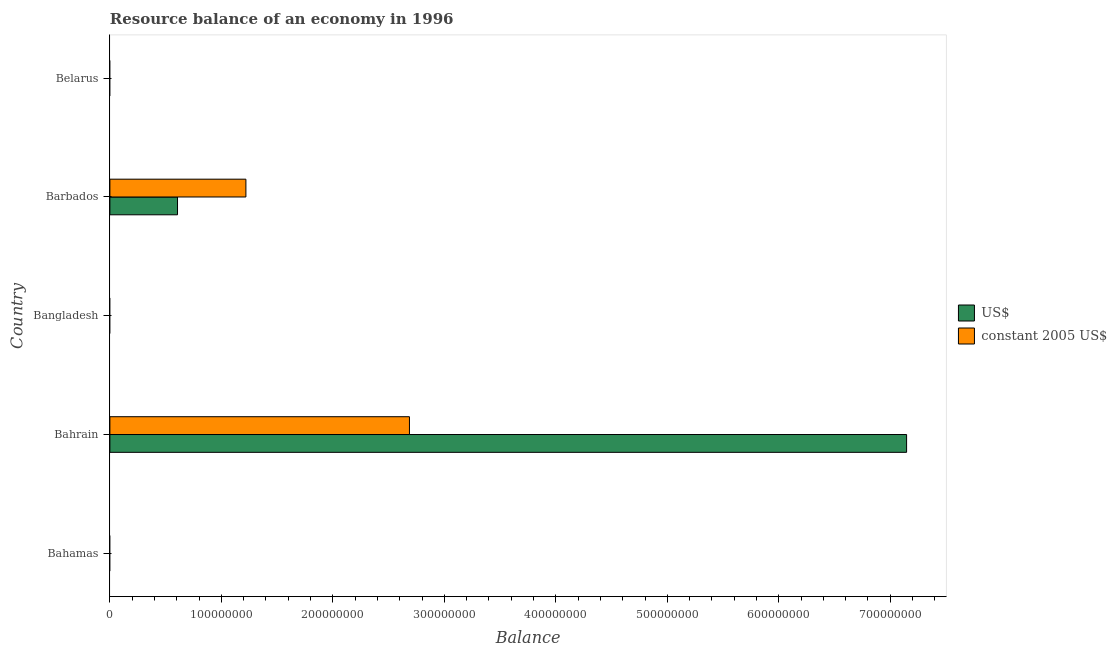How many bars are there on the 5th tick from the top?
Ensure brevity in your answer.  0. What is the label of the 5th group of bars from the top?
Ensure brevity in your answer.  Bahamas. Across all countries, what is the maximum resource balance in constant us$?
Make the answer very short. 2.69e+08. In which country was the resource balance in constant us$ maximum?
Provide a short and direct response. Bahrain. What is the total resource balance in constant us$ in the graph?
Provide a short and direct response. 3.91e+08. What is the difference between the resource balance in us$ in Bangladesh and the resource balance in constant us$ in Bahrain?
Your response must be concise. -2.69e+08. What is the average resource balance in constant us$ per country?
Give a very brief answer. 7.81e+07. What is the difference between the resource balance in us$ and resource balance in constant us$ in Barbados?
Make the answer very short. -6.13e+07. In how many countries, is the resource balance in constant us$ greater than 520000000 units?
Ensure brevity in your answer.  0. What is the difference between the highest and the lowest resource balance in us$?
Ensure brevity in your answer.  7.15e+08. In how many countries, is the resource balance in us$ greater than the average resource balance in us$ taken over all countries?
Provide a short and direct response. 1. How many countries are there in the graph?
Offer a very short reply. 5. How are the legend labels stacked?
Give a very brief answer. Vertical. What is the title of the graph?
Ensure brevity in your answer.  Resource balance of an economy in 1996. What is the label or title of the X-axis?
Provide a succinct answer. Balance. What is the label or title of the Y-axis?
Ensure brevity in your answer.  Country. What is the Balance of US$ in Bahamas?
Offer a very short reply. 0. What is the Balance of US$ in Bahrain?
Your answer should be compact. 7.15e+08. What is the Balance in constant 2005 US$ in Bahrain?
Your answer should be compact. 2.69e+08. What is the Balance of US$ in Barbados?
Keep it short and to the point. 6.07e+07. What is the Balance in constant 2005 US$ in Barbados?
Make the answer very short. 1.22e+08. What is the Balance of US$ in Belarus?
Your answer should be compact. 0. Across all countries, what is the maximum Balance in US$?
Make the answer very short. 7.15e+08. Across all countries, what is the maximum Balance of constant 2005 US$?
Your answer should be very brief. 2.69e+08. Across all countries, what is the minimum Balance of US$?
Your answer should be compact. 0. What is the total Balance of US$ in the graph?
Your response must be concise. 7.75e+08. What is the total Balance in constant 2005 US$ in the graph?
Ensure brevity in your answer.  3.91e+08. What is the difference between the Balance in US$ in Bahrain and that in Barbados?
Your answer should be compact. 6.54e+08. What is the difference between the Balance in constant 2005 US$ in Bahrain and that in Barbados?
Your answer should be compact. 1.47e+08. What is the difference between the Balance in US$ in Bahrain and the Balance in constant 2005 US$ in Barbados?
Your answer should be very brief. 5.93e+08. What is the average Balance of US$ per country?
Offer a very short reply. 1.55e+08. What is the average Balance of constant 2005 US$ per country?
Give a very brief answer. 7.81e+07. What is the difference between the Balance of US$ and Balance of constant 2005 US$ in Bahrain?
Your answer should be very brief. 4.46e+08. What is the difference between the Balance of US$ and Balance of constant 2005 US$ in Barbados?
Give a very brief answer. -6.13e+07. What is the ratio of the Balance of US$ in Bahrain to that in Barbados?
Give a very brief answer. 11.78. What is the ratio of the Balance of constant 2005 US$ in Bahrain to that in Barbados?
Give a very brief answer. 2.2. What is the difference between the highest and the lowest Balance of US$?
Your answer should be compact. 7.15e+08. What is the difference between the highest and the lowest Balance in constant 2005 US$?
Provide a short and direct response. 2.69e+08. 